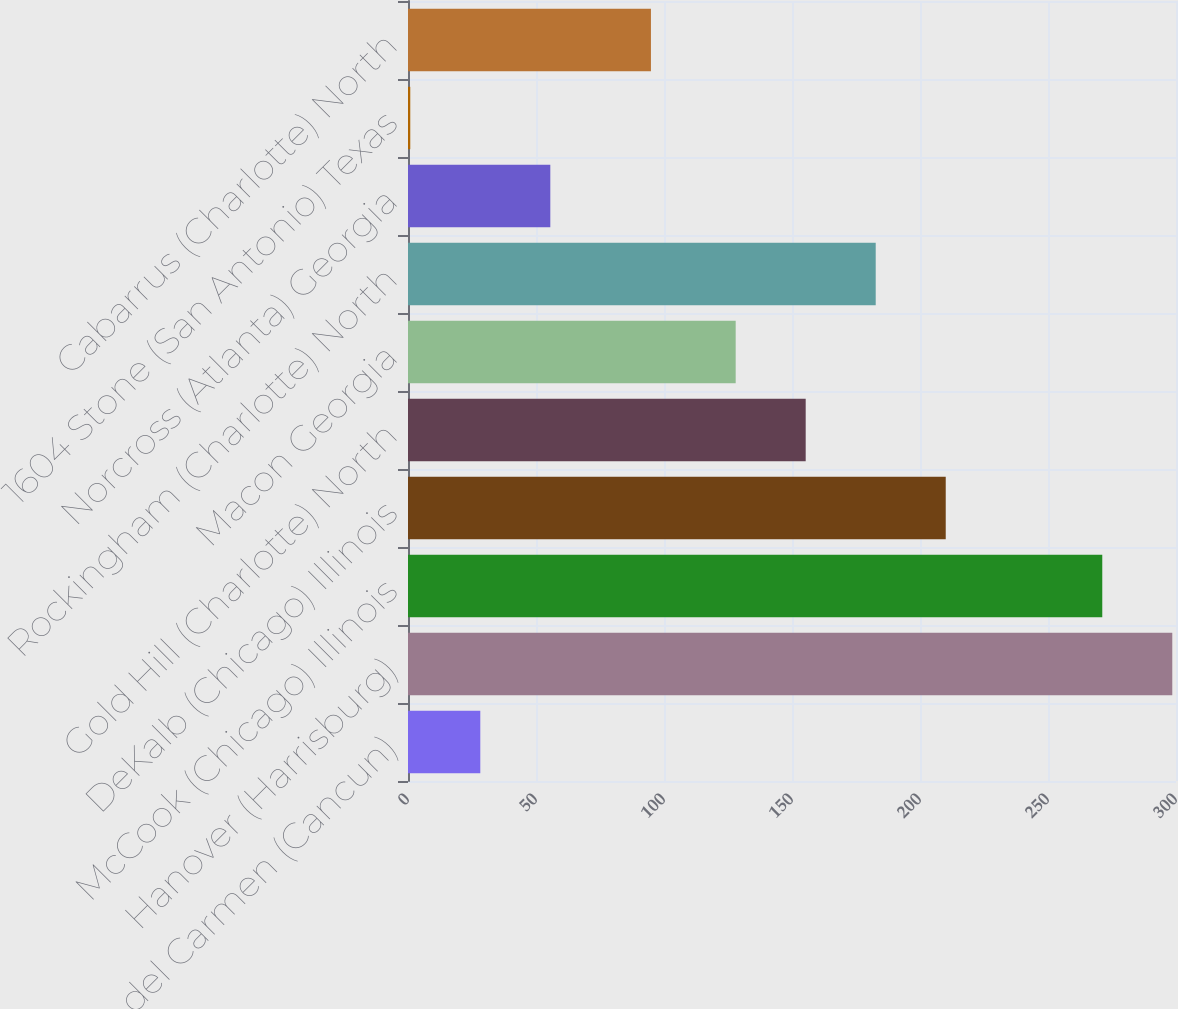Convert chart to OTSL. <chart><loc_0><loc_0><loc_500><loc_500><bar_chart><fcel>Playa del Carmen (Cancun)<fcel>Hanover (Harrisburg)<fcel>McCook (Chicago) Illinois<fcel>DeKalb (Chicago) Illinois<fcel>Gold Hill (Charlotte) North<fcel>Macon Georgia<fcel>Rockingham (Charlotte) North<fcel>Norcross (Atlanta) Georgia<fcel>1604 Stone (San Antonio) Texas<fcel>Cabarrus (Charlotte) North<nl><fcel>28.24<fcel>298.55<fcel>271.2<fcel>210.05<fcel>155.35<fcel>128<fcel>182.7<fcel>55.59<fcel>0.89<fcel>94.9<nl></chart> 